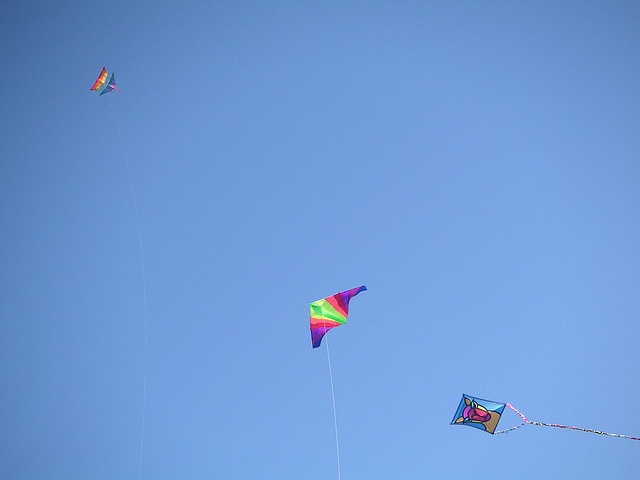Describe the objects in this image and their specific colors. I can see kite in blue and lightblue tones, kite in blue, lightgreen, purple, and salmon tones, and kite in blue and gray tones in this image. 